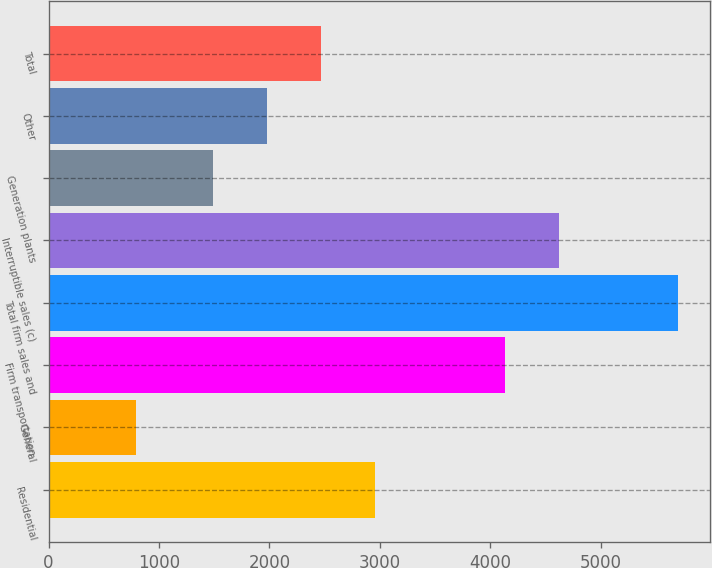<chart> <loc_0><loc_0><loc_500><loc_500><bar_chart><fcel>Residential<fcel>General<fcel>Firm transportation<fcel>Total firm sales and<fcel>Interruptible sales (c)<fcel>Generation plants<fcel>Other<fcel>Total<nl><fcel>2959.2<fcel>796<fcel>4133<fcel>5700<fcel>4623.4<fcel>1488<fcel>1978.4<fcel>2468.8<nl></chart> 